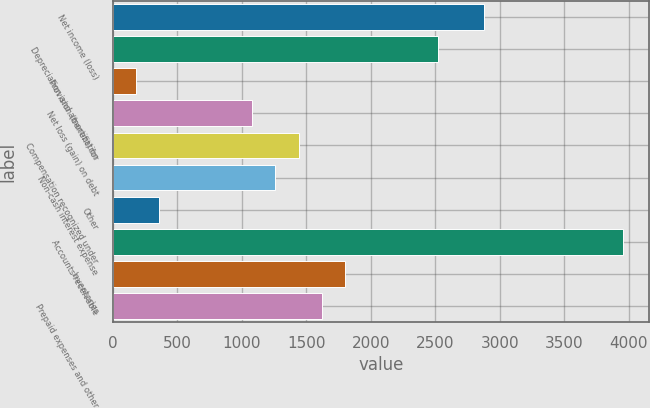<chart> <loc_0><loc_0><loc_500><loc_500><bar_chart><fcel>Net income (loss)<fcel>Depreciation and amortization<fcel>Provision (benefit) for<fcel>Net loss (gain) on debt<fcel>Compensation recognized under<fcel>Non-cash interest expense<fcel>Other<fcel>Accounts receivable<fcel>Inventories<fcel>Prepaid expenses and other<nl><fcel>2878.8<fcel>2519.2<fcel>181.8<fcel>1080.8<fcel>1440.4<fcel>1260.6<fcel>361.6<fcel>3957.6<fcel>1800<fcel>1620.2<nl></chart> 